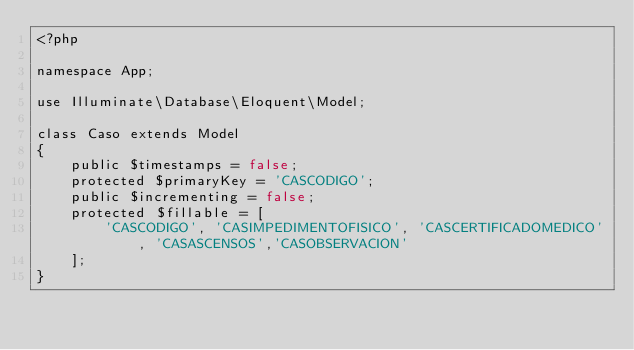<code> <loc_0><loc_0><loc_500><loc_500><_PHP_><?php

namespace App;

use Illuminate\Database\Eloquent\Model;

class Caso extends Model
{
    public $timestamps = false;
    protected $primaryKey = 'CASCODIGO';
    public $incrementing = false;
    protected $fillable = [
        'CASCODIGO', 'CASIMPEDIMENTOFISICO', 'CASCERTIFICADOMEDICO', 'CASASCENSOS','CASOBSERVACION'
    ];
}
</code> 